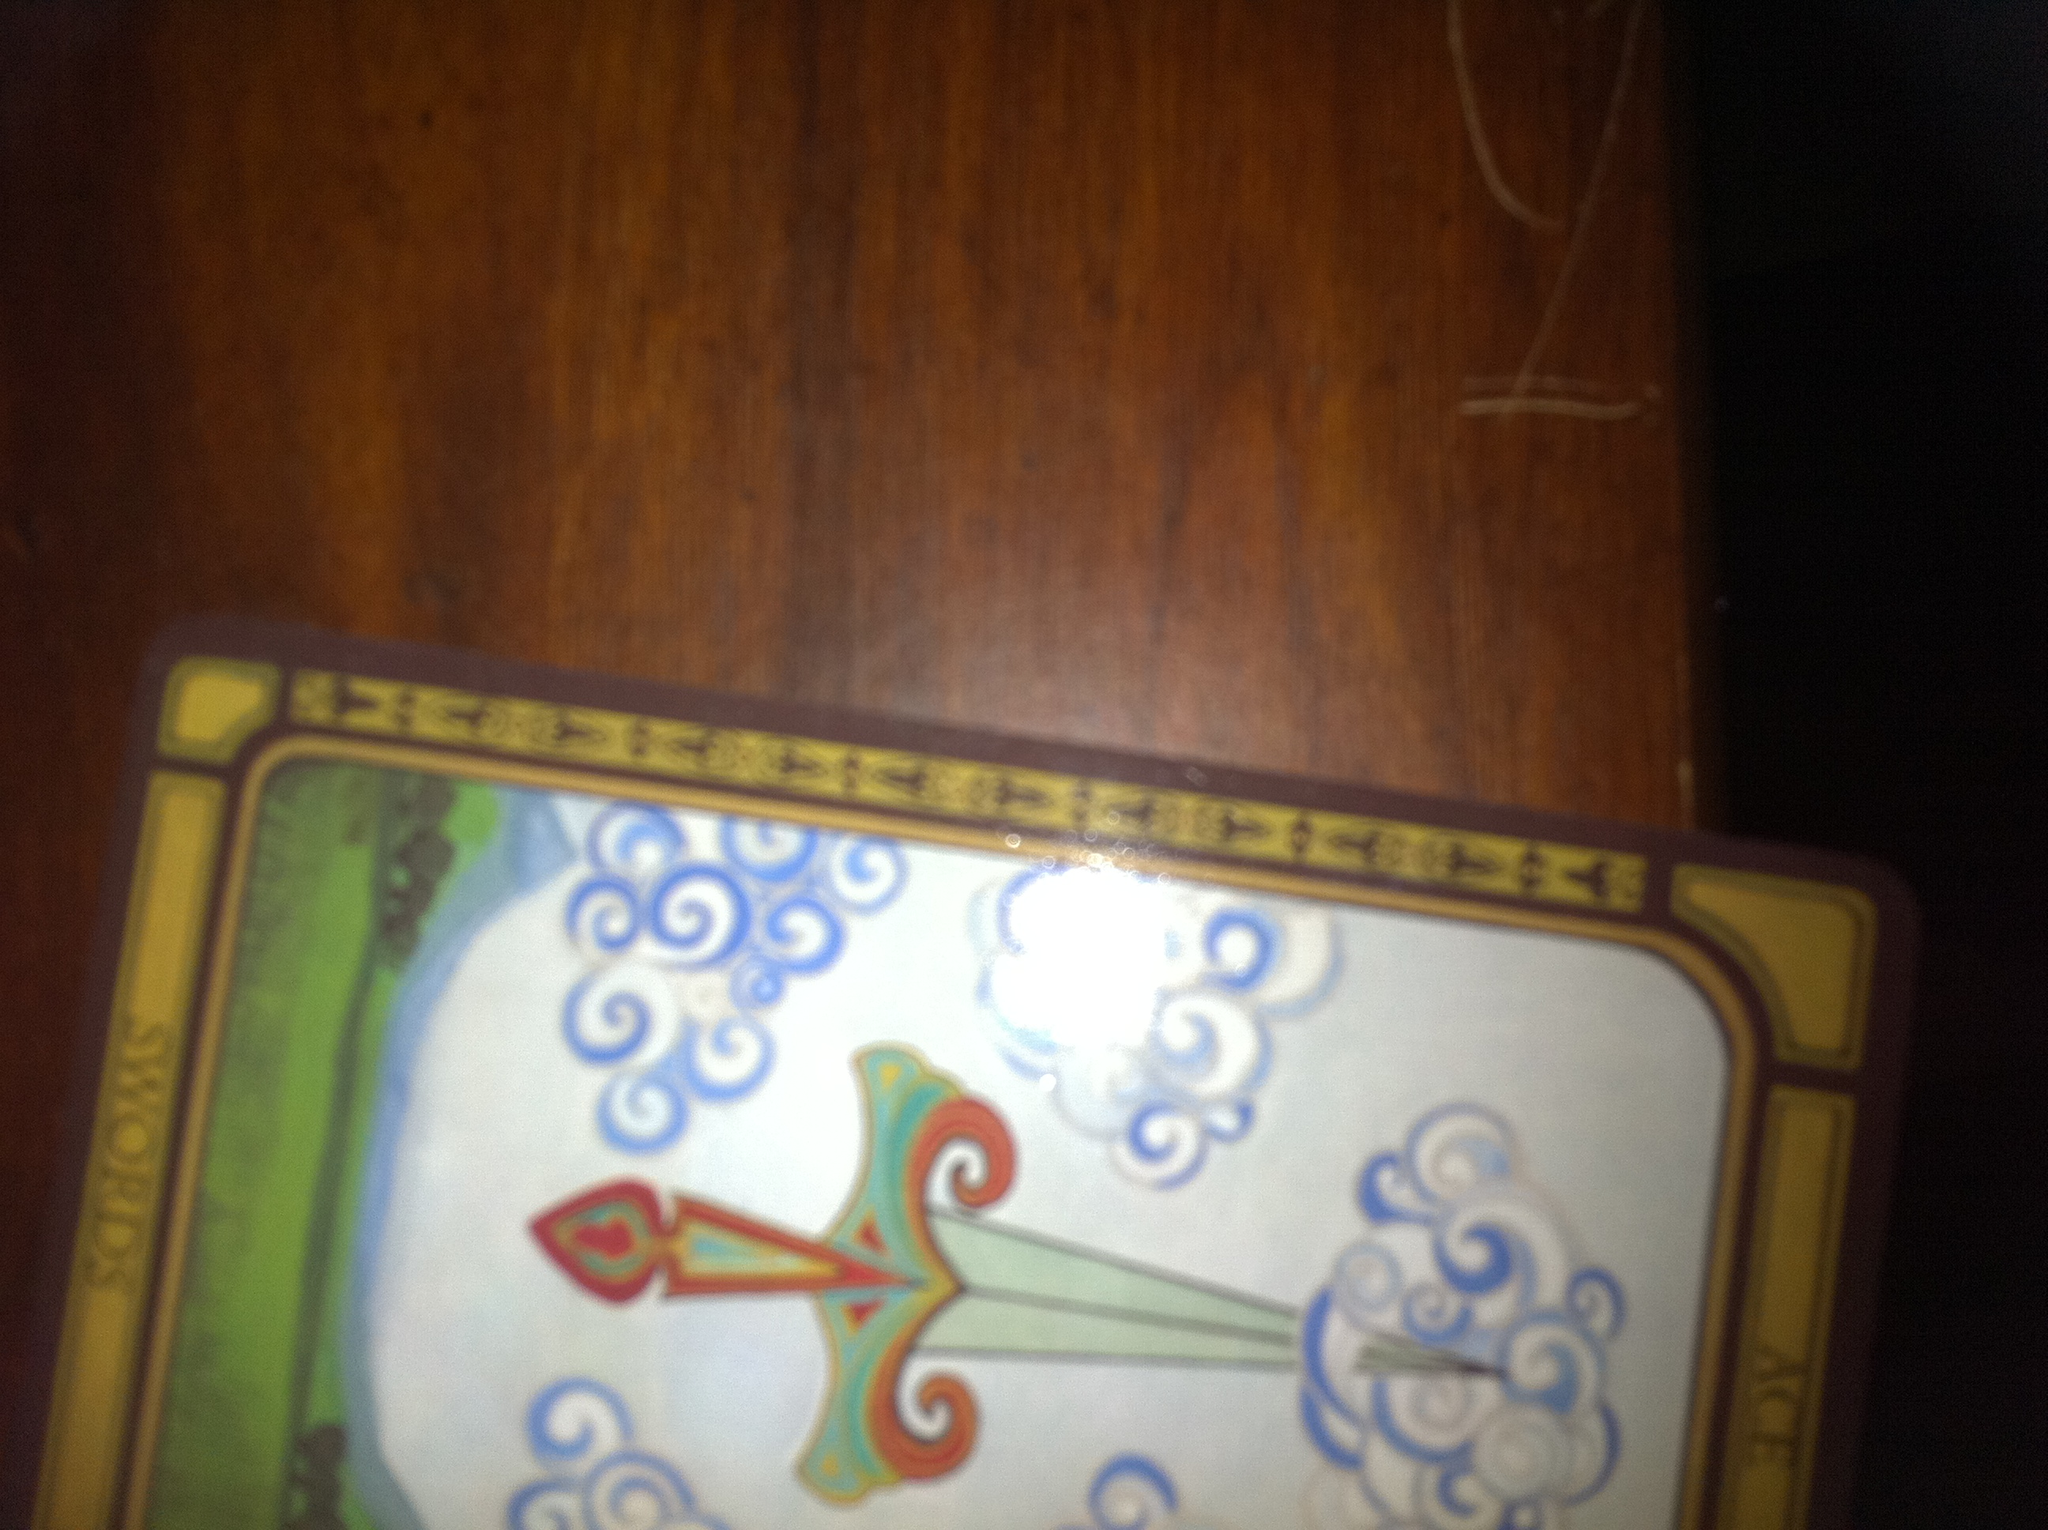What card is this and can you describe it's orientation, thank you? This is the Ace of Swords card. It is currently placed in a landscape orientation, meaning it is positioned horizontally rather than vertically. The hilt of the sword is facing the left side, and the point of the sword is directed towards the right side. 